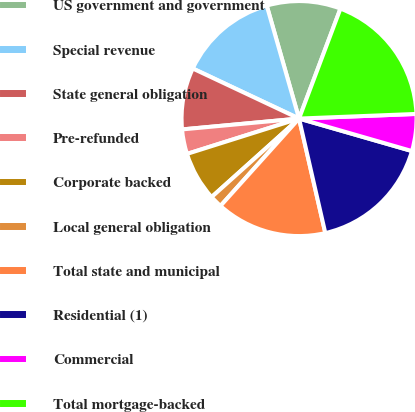<chart> <loc_0><loc_0><loc_500><loc_500><pie_chart><fcel>US government and government<fcel>Special revenue<fcel>State general obligation<fcel>Pre-refunded<fcel>Corporate backed<fcel>Local general obligation<fcel>Total state and municipal<fcel>Residential (1)<fcel>Commercial<fcel>Total mortgage-backed<nl><fcel>10.17%<fcel>13.56%<fcel>8.48%<fcel>3.39%<fcel>6.78%<fcel>1.7%<fcel>15.25%<fcel>16.95%<fcel>5.09%<fcel>18.64%<nl></chart> 